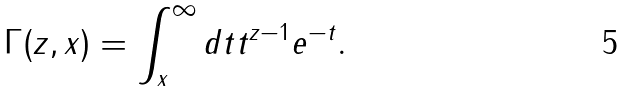<formula> <loc_0><loc_0><loc_500><loc_500>\Gamma ( z , x ) = \int _ { x } ^ { \infty } d t t ^ { z - 1 } e ^ { - t } .</formula> 